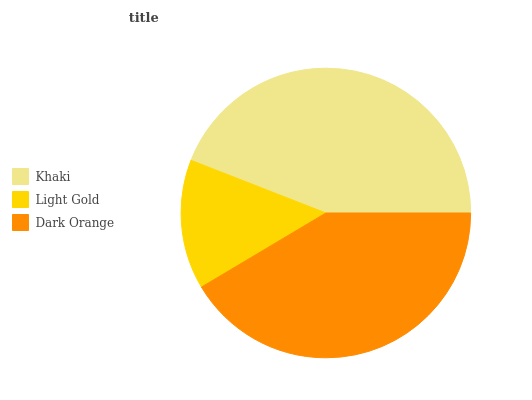Is Light Gold the minimum?
Answer yes or no. Yes. Is Khaki the maximum?
Answer yes or no. Yes. Is Dark Orange the minimum?
Answer yes or no. No. Is Dark Orange the maximum?
Answer yes or no. No. Is Dark Orange greater than Light Gold?
Answer yes or no. Yes. Is Light Gold less than Dark Orange?
Answer yes or no. Yes. Is Light Gold greater than Dark Orange?
Answer yes or no. No. Is Dark Orange less than Light Gold?
Answer yes or no. No. Is Dark Orange the high median?
Answer yes or no. Yes. Is Dark Orange the low median?
Answer yes or no. Yes. Is Light Gold the high median?
Answer yes or no. No. Is Light Gold the low median?
Answer yes or no. No. 